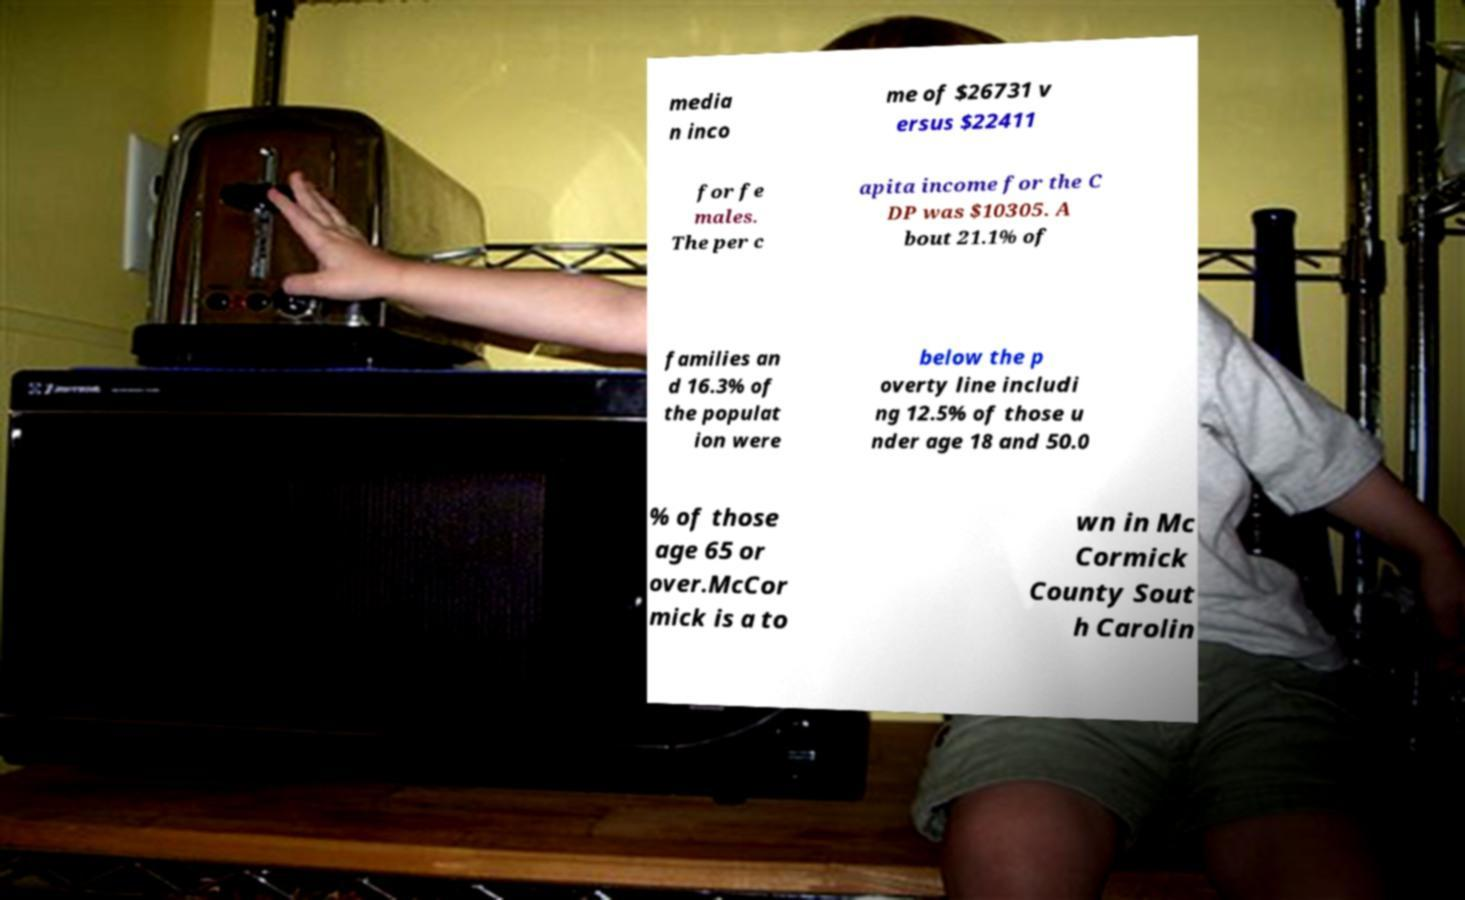What messages or text are displayed in this image? I need them in a readable, typed format. media n inco me of $26731 v ersus $22411 for fe males. The per c apita income for the C DP was $10305. A bout 21.1% of families an d 16.3% of the populat ion were below the p overty line includi ng 12.5% of those u nder age 18 and 50.0 % of those age 65 or over.McCor mick is a to wn in Mc Cormick County Sout h Carolin 